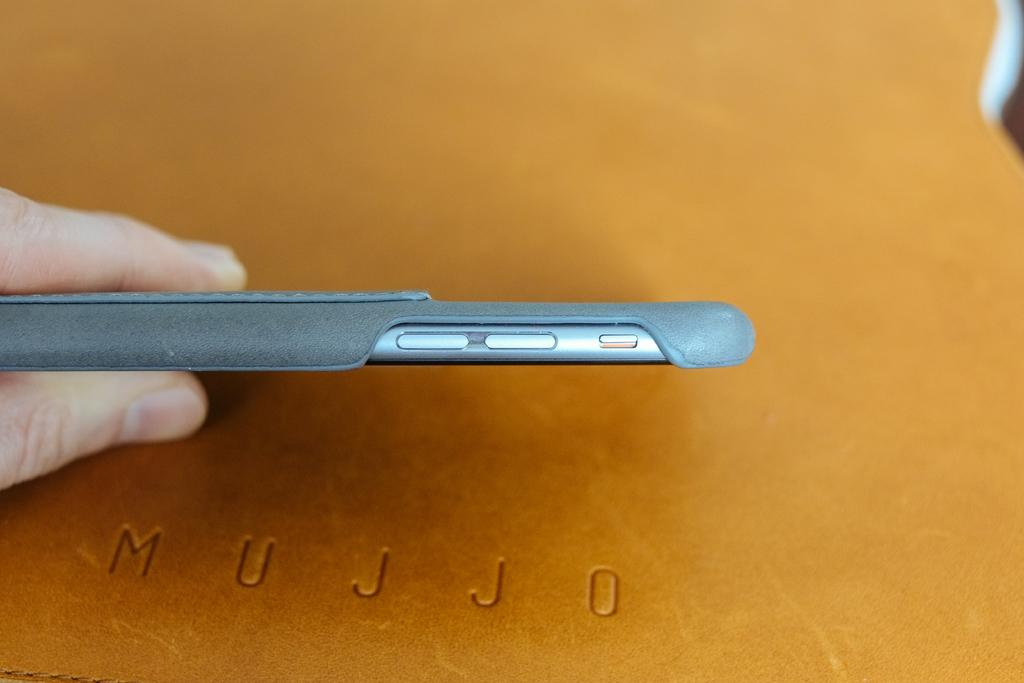<image>
Summarize the visual content of the image. the side of a phone being held over the word mujjo 